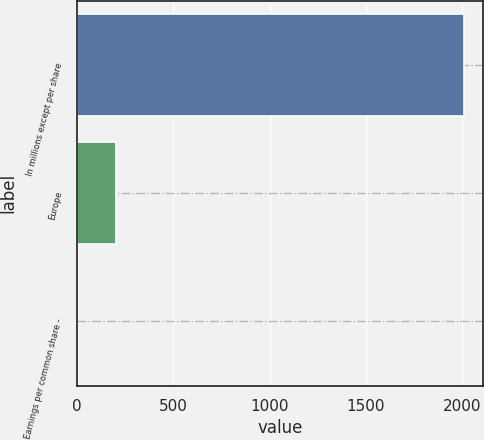Convert chart to OTSL. <chart><loc_0><loc_0><loc_500><loc_500><bar_chart><fcel>In millions except per share<fcel>Europe<fcel>Earnings per common share -<nl><fcel>2008<fcel>200.81<fcel>0.01<nl></chart> 